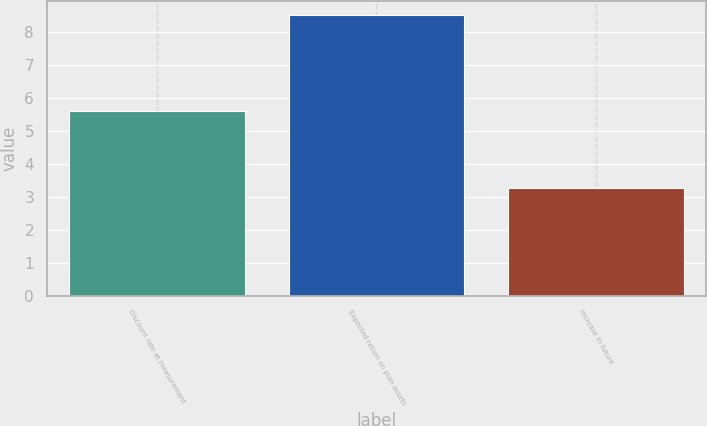Convert chart. <chart><loc_0><loc_0><loc_500><loc_500><bar_chart><fcel>Discount rate at measurement<fcel>Expected return on plan assets<fcel>Increase in future<nl><fcel>5.6<fcel>8.5<fcel>3.25<nl></chart> 